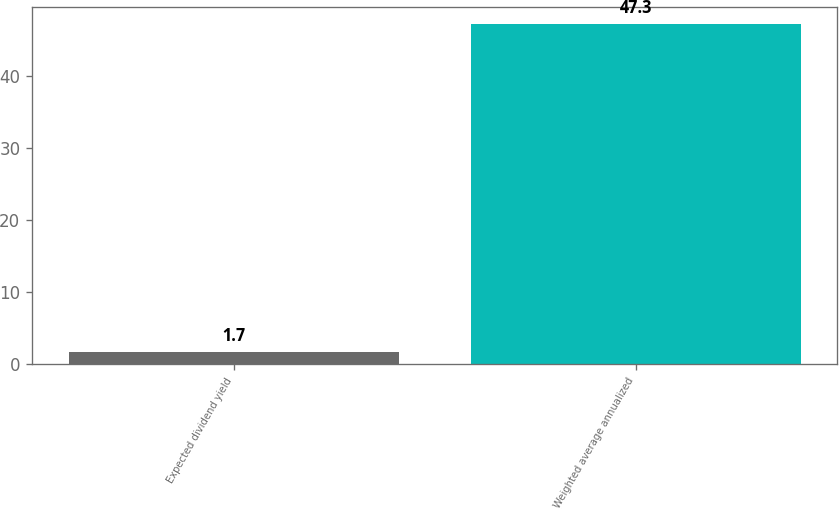Convert chart to OTSL. <chart><loc_0><loc_0><loc_500><loc_500><bar_chart><fcel>Expected dividend yield<fcel>Weighted average annualized<nl><fcel>1.7<fcel>47.3<nl></chart> 